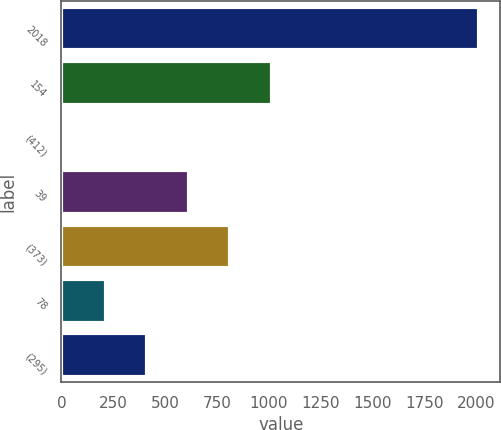<chart> <loc_0><loc_0><loc_500><loc_500><bar_chart><fcel>2018<fcel>154<fcel>(412)<fcel>39<fcel>(373)<fcel>78<fcel>(295)<nl><fcel>2017<fcel>1015.5<fcel>14<fcel>614.9<fcel>815.2<fcel>214.3<fcel>414.6<nl></chart> 